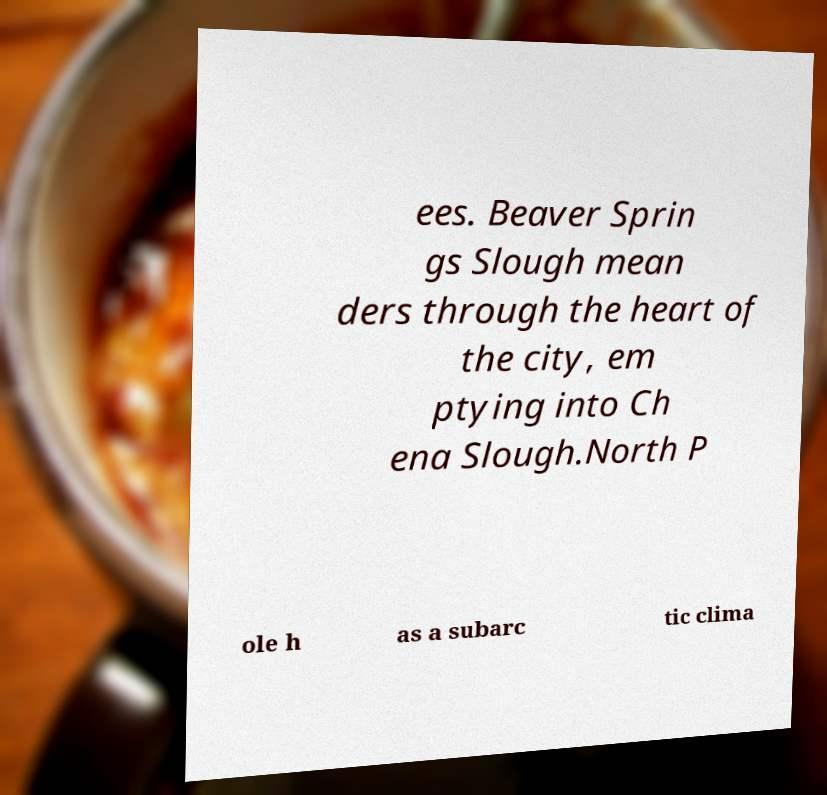Can you accurately transcribe the text from the provided image for me? ees. Beaver Sprin gs Slough mean ders through the heart of the city, em ptying into Ch ena Slough.North P ole h as a subarc tic clima 